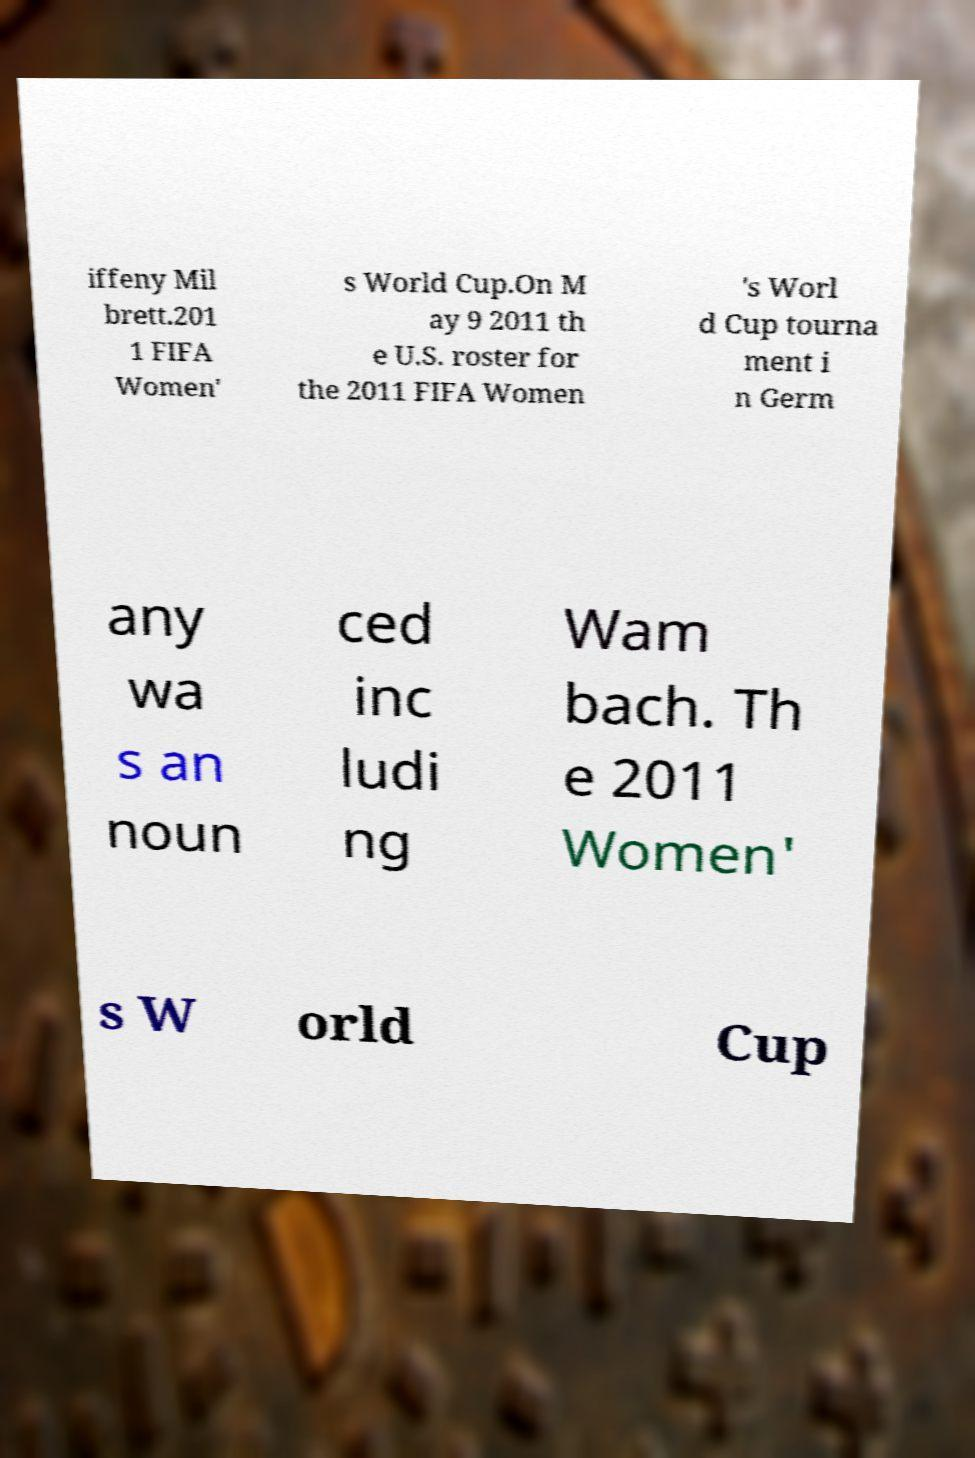Can you accurately transcribe the text from the provided image for me? iffeny Mil brett.201 1 FIFA Women' s World Cup.On M ay 9 2011 th e U.S. roster for the 2011 FIFA Women 's Worl d Cup tourna ment i n Germ any wa s an noun ced inc ludi ng Wam bach. Th e 2011 Women' s W orld Cup 